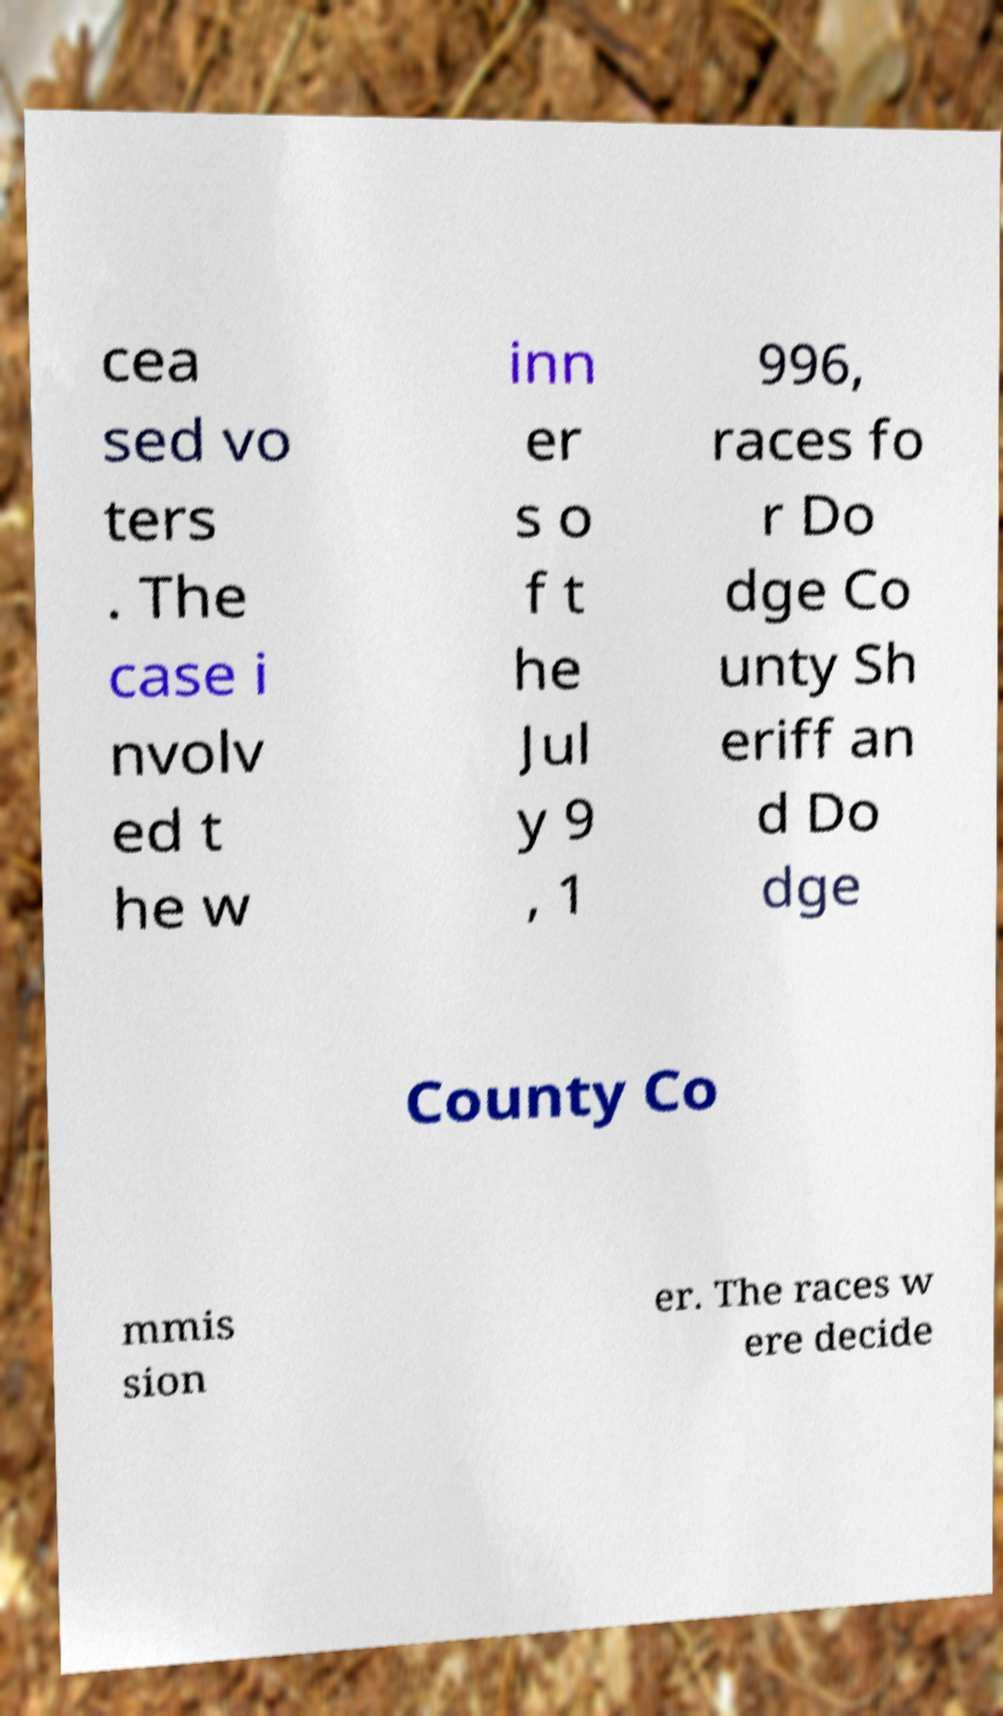Could you extract and type out the text from this image? cea sed vo ters . The case i nvolv ed t he w inn er s o f t he Jul y 9 , 1 996, races fo r Do dge Co unty Sh eriff an d Do dge County Co mmis sion er. The races w ere decide 